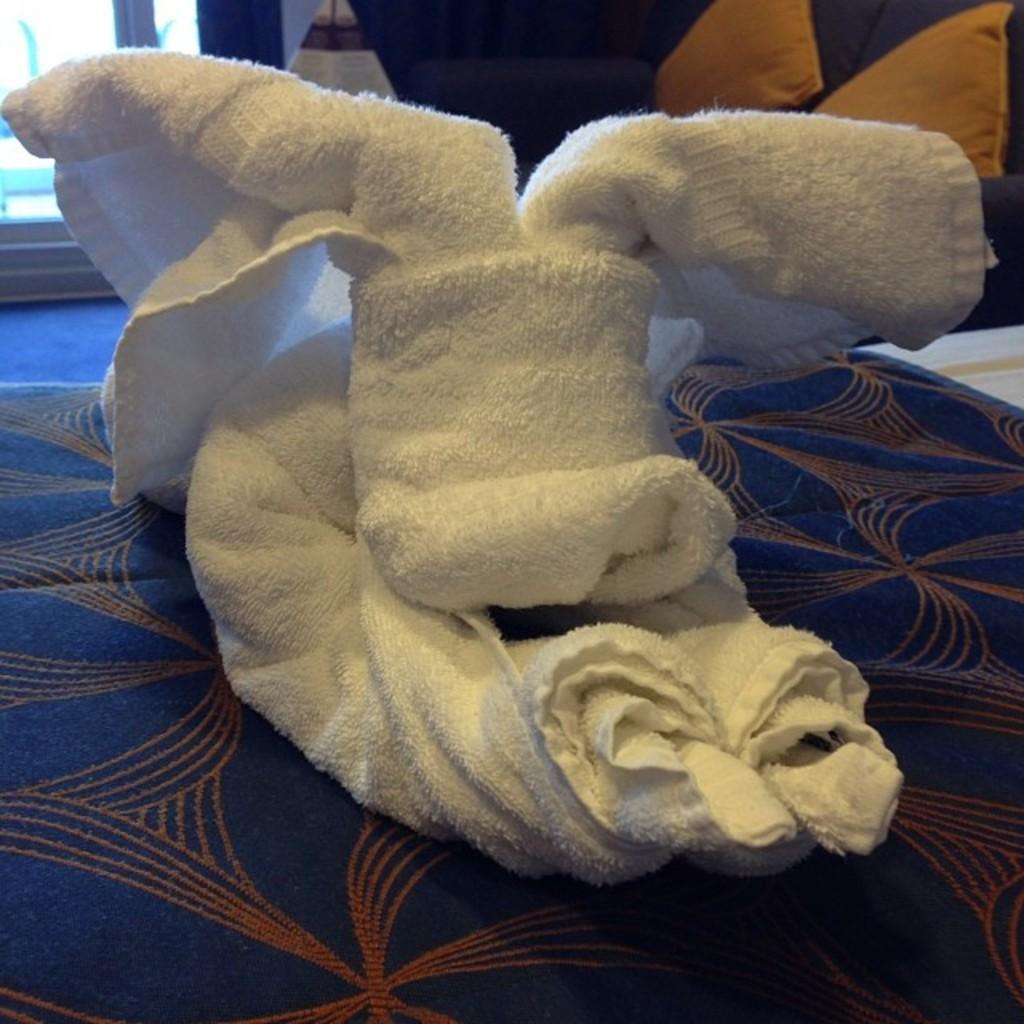Describe this image in one or two sentences. In this picture, it looks like a bed and on the bed there is a white towel. Behind the towel there are some objects. 